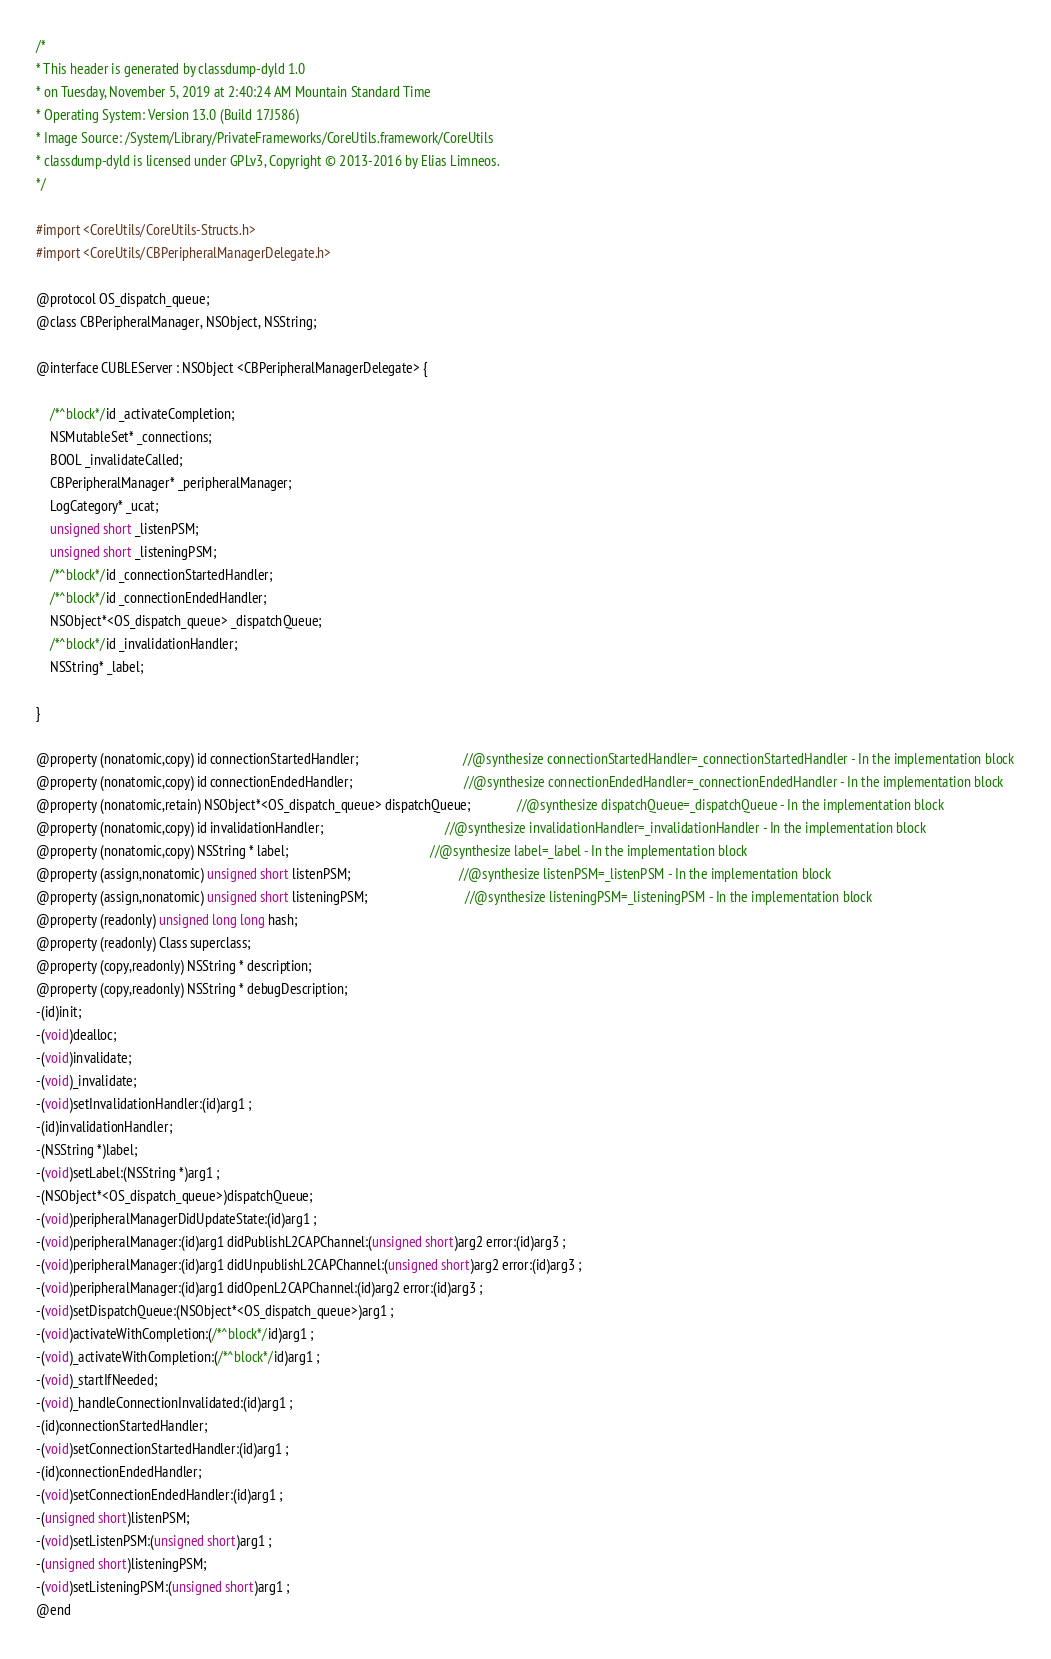<code> <loc_0><loc_0><loc_500><loc_500><_C_>/*
* This header is generated by classdump-dyld 1.0
* on Tuesday, November 5, 2019 at 2:40:24 AM Mountain Standard Time
* Operating System: Version 13.0 (Build 17J586)
* Image Source: /System/Library/PrivateFrameworks/CoreUtils.framework/CoreUtils
* classdump-dyld is licensed under GPLv3, Copyright © 2013-2016 by Elias Limneos.
*/

#import <CoreUtils/CoreUtils-Structs.h>
#import <CoreUtils/CBPeripheralManagerDelegate.h>

@protocol OS_dispatch_queue;
@class CBPeripheralManager, NSObject, NSString;

@interface CUBLEServer : NSObject <CBPeripheralManagerDelegate> {

	/*^block*/id _activateCompletion;
	NSMutableSet* _connections;
	BOOL _invalidateCalled;
	CBPeripheralManager* _peripheralManager;
	LogCategory* _ucat;
	unsigned short _listenPSM;
	unsigned short _listeningPSM;
	/*^block*/id _connectionStartedHandler;
	/*^block*/id _connectionEndedHandler;
	NSObject*<OS_dispatch_queue> _dispatchQueue;
	/*^block*/id _invalidationHandler;
	NSString* _label;

}

@property (nonatomic,copy) id connectionStartedHandler;                               //@synthesize connectionStartedHandler=_connectionStartedHandler - In the implementation block
@property (nonatomic,copy) id connectionEndedHandler;                                 //@synthesize connectionEndedHandler=_connectionEndedHandler - In the implementation block
@property (nonatomic,retain) NSObject*<OS_dispatch_queue> dispatchQueue;              //@synthesize dispatchQueue=_dispatchQueue - In the implementation block
@property (nonatomic,copy) id invalidationHandler;                                    //@synthesize invalidationHandler=_invalidationHandler - In the implementation block
@property (nonatomic,copy) NSString * label;                                          //@synthesize label=_label - In the implementation block
@property (assign,nonatomic) unsigned short listenPSM;                                //@synthesize listenPSM=_listenPSM - In the implementation block
@property (assign,nonatomic) unsigned short listeningPSM;                             //@synthesize listeningPSM=_listeningPSM - In the implementation block
@property (readonly) unsigned long long hash; 
@property (readonly) Class superclass; 
@property (copy,readonly) NSString * description; 
@property (copy,readonly) NSString * debugDescription; 
-(id)init;
-(void)dealloc;
-(void)invalidate;
-(void)_invalidate;
-(void)setInvalidationHandler:(id)arg1 ;
-(id)invalidationHandler;
-(NSString *)label;
-(void)setLabel:(NSString *)arg1 ;
-(NSObject*<OS_dispatch_queue>)dispatchQueue;
-(void)peripheralManagerDidUpdateState:(id)arg1 ;
-(void)peripheralManager:(id)arg1 didPublishL2CAPChannel:(unsigned short)arg2 error:(id)arg3 ;
-(void)peripheralManager:(id)arg1 didUnpublishL2CAPChannel:(unsigned short)arg2 error:(id)arg3 ;
-(void)peripheralManager:(id)arg1 didOpenL2CAPChannel:(id)arg2 error:(id)arg3 ;
-(void)setDispatchQueue:(NSObject*<OS_dispatch_queue>)arg1 ;
-(void)activateWithCompletion:(/*^block*/id)arg1 ;
-(void)_activateWithCompletion:(/*^block*/id)arg1 ;
-(void)_startIfNeeded;
-(void)_handleConnectionInvalidated:(id)arg1 ;
-(id)connectionStartedHandler;
-(void)setConnectionStartedHandler:(id)arg1 ;
-(id)connectionEndedHandler;
-(void)setConnectionEndedHandler:(id)arg1 ;
-(unsigned short)listenPSM;
-(void)setListenPSM:(unsigned short)arg1 ;
-(unsigned short)listeningPSM;
-(void)setListeningPSM:(unsigned short)arg1 ;
@end

</code> 